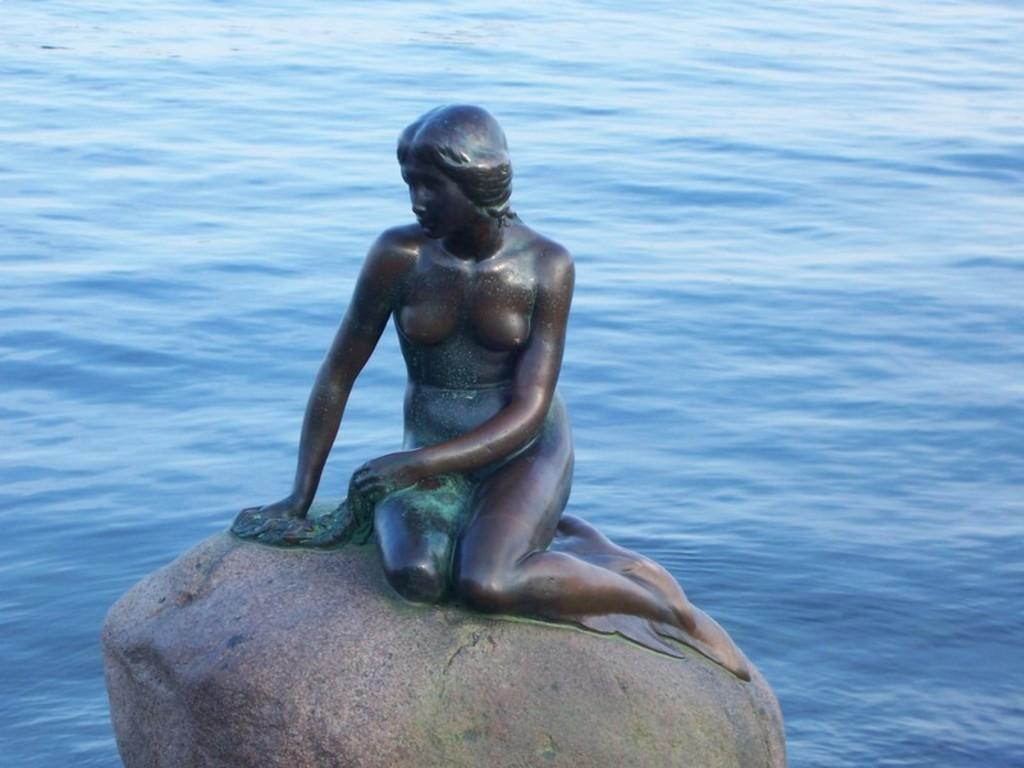What is the main subject of the image? There is a metal statue of a lady in the image. Where is the statue located? The statue is on top of a rock. What can be seen in the background of the image? There is water visible behind the statue. What type of fuel is the statue using to maintain its position on the rock? The statue does not use any fuel to maintain its position on the rock; it is a stationary object. How does the statue contribute to the profit of the nearby business? The statue is not associated with any business, so it does not contribute to any profit. 